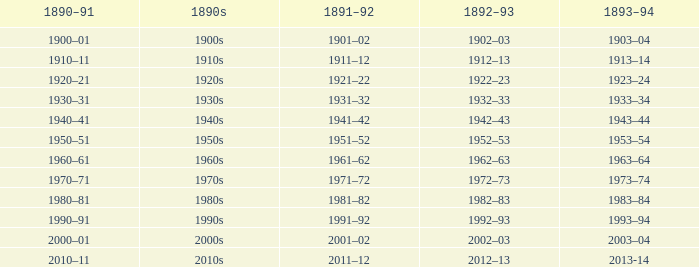What is the year from 1892-93 that has the 1890s to the 1940s? 1942–43. 